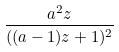Convert formula to latex. <formula><loc_0><loc_0><loc_500><loc_500>\frac { a ^ { 2 } z } { ( ( a - 1 ) z + 1 ) ^ { 2 } }</formula> 